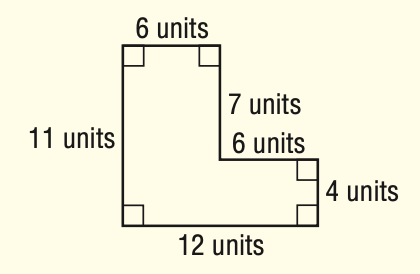Answer the mathemtical geometry problem and directly provide the correct option letter.
Question: What is the perimeter of the figure?
Choices: A: 20 B: 46 C: 90 D: 132 A 